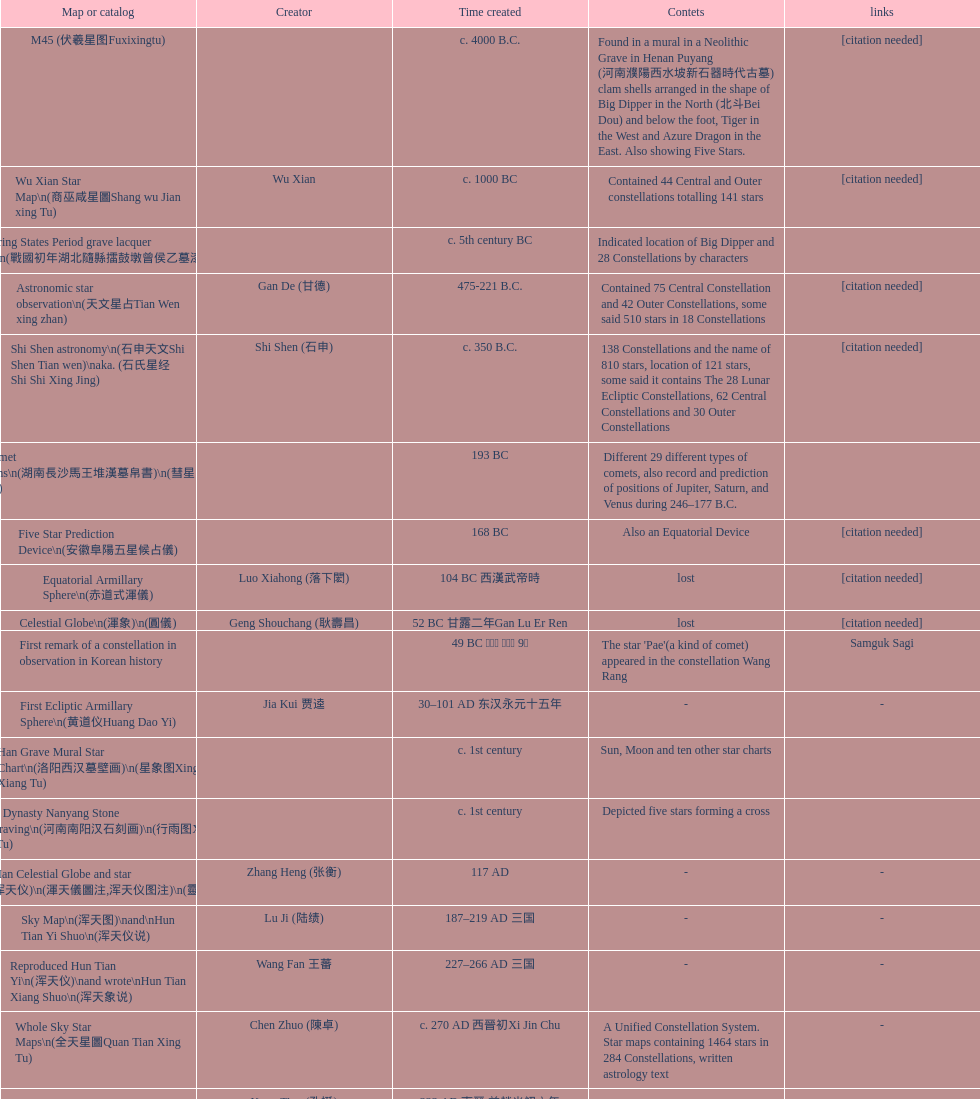Which star map was developed first, celestial sphere or the han tomb mural star diagram? Celestial Globe. 